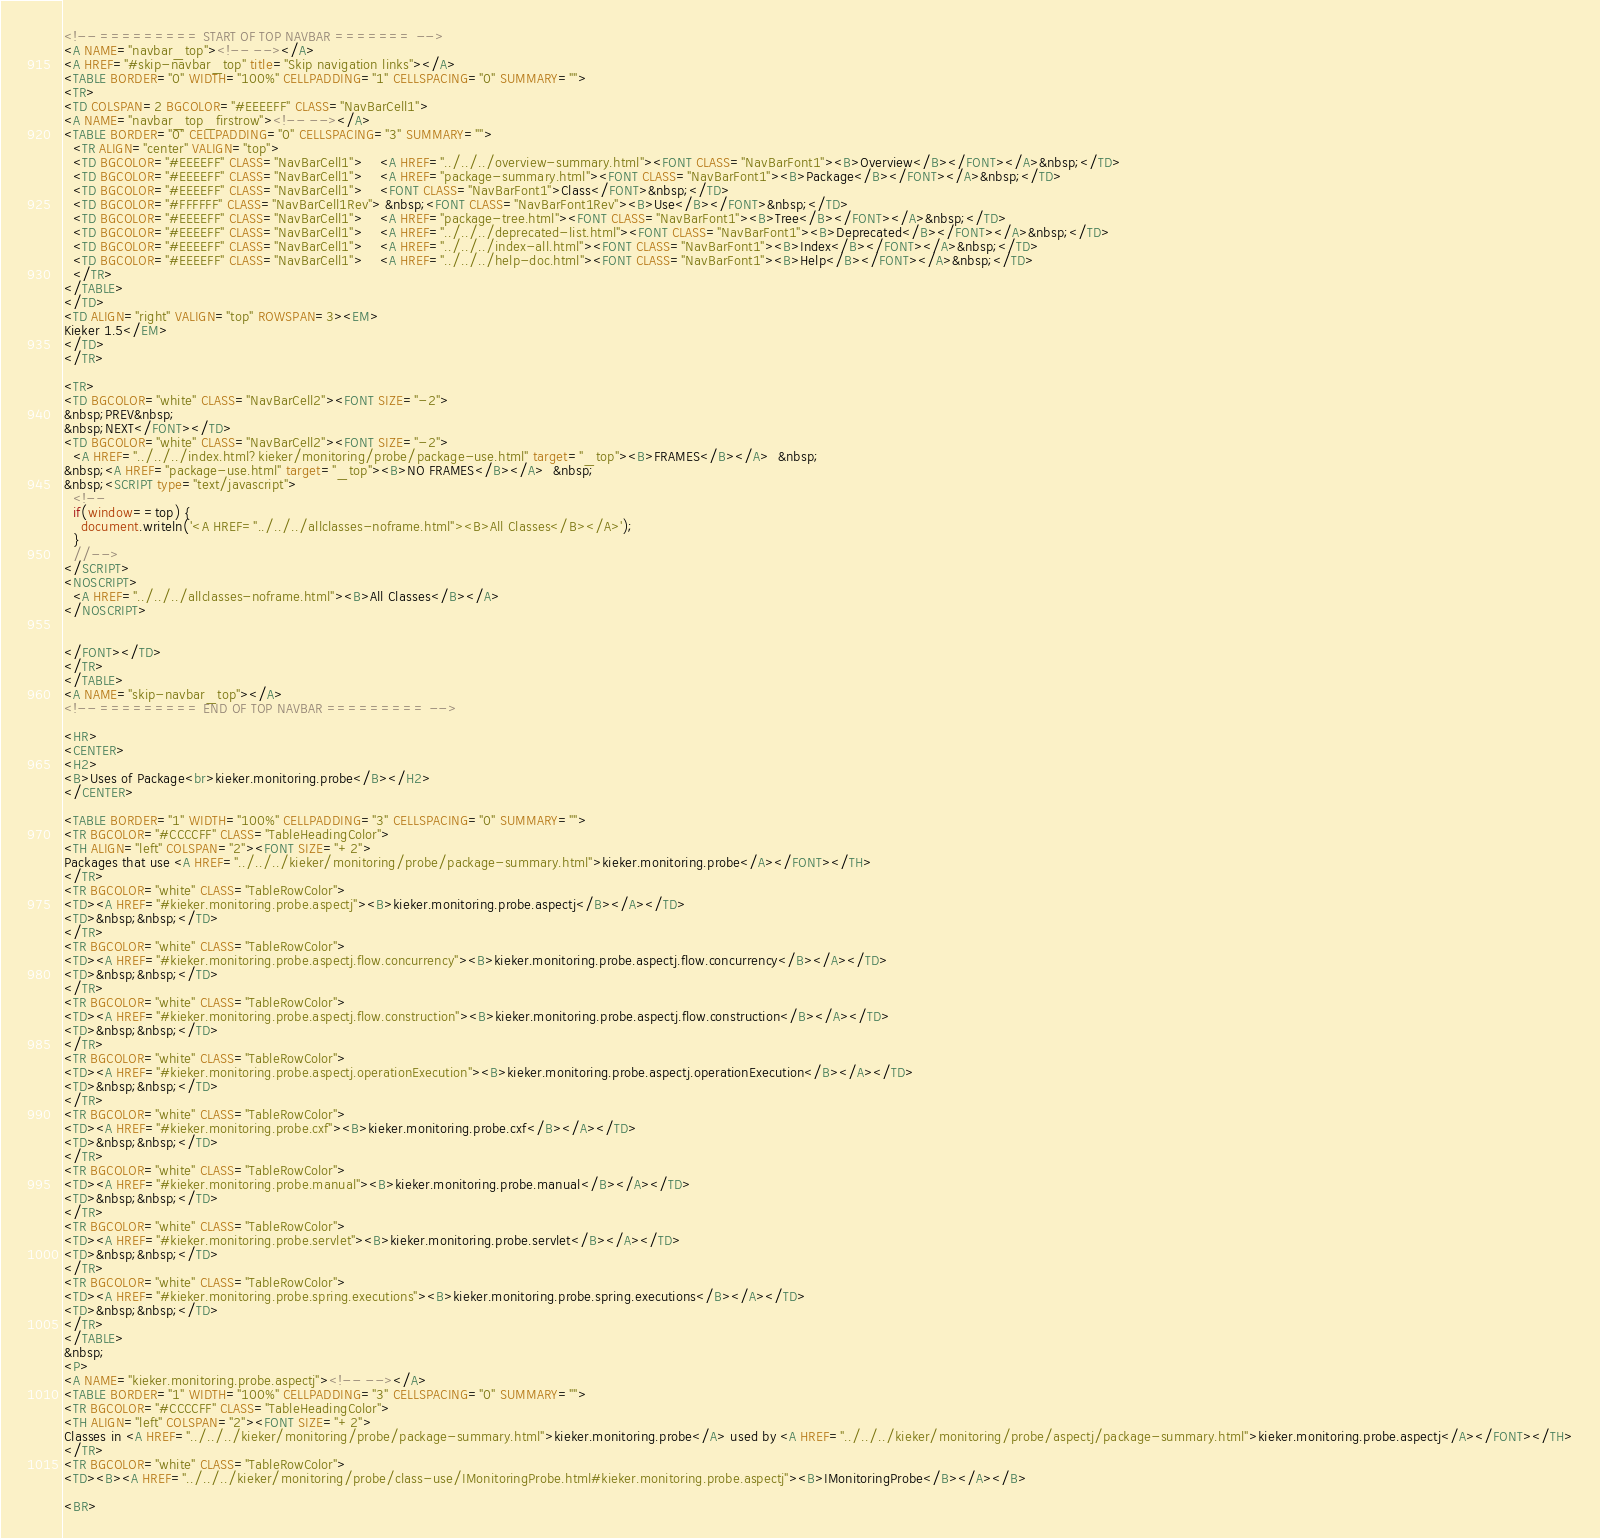Convert code to text. <code><loc_0><loc_0><loc_500><loc_500><_HTML_>
<!-- ========= START OF TOP NAVBAR ======= -->
<A NAME="navbar_top"><!-- --></A>
<A HREF="#skip-navbar_top" title="Skip navigation links"></A>
<TABLE BORDER="0" WIDTH="100%" CELLPADDING="1" CELLSPACING="0" SUMMARY="">
<TR>
<TD COLSPAN=2 BGCOLOR="#EEEEFF" CLASS="NavBarCell1">
<A NAME="navbar_top_firstrow"><!-- --></A>
<TABLE BORDER="0" CELLPADDING="0" CELLSPACING="3" SUMMARY="">
  <TR ALIGN="center" VALIGN="top">
  <TD BGCOLOR="#EEEEFF" CLASS="NavBarCell1">    <A HREF="../../../overview-summary.html"><FONT CLASS="NavBarFont1"><B>Overview</B></FONT></A>&nbsp;</TD>
  <TD BGCOLOR="#EEEEFF" CLASS="NavBarCell1">    <A HREF="package-summary.html"><FONT CLASS="NavBarFont1"><B>Package</B></FONT></A>&nbsp;</TD>
  <TD BGCOLOR="#EEEEFF" CLASS="NavBarCell1">    <FONT CLASS="NavBarFont1">Class</FONT>&nbsp;</TD>
  <TD BGCOLOR="#FFFFFF" CLASS="NavBarCell1Rev"> &nbsp;<FONT CLASS="NavBarFont1Rev"><B>Use</B></FONT>&nbsp;</TD>
  <TD BGCOLOR="#EEEEFF" CLASS="NavBarCell1">    <A HREF="package-tree.html"><FONT CLASS="NavBarFont1"><B>Tree</B></FONT></A>&nbsp;</TD>
  <TD BGCOLOR="#EEEEFF" CLASS="NavBarCell1">    <A HREF="../../../deprecated-list.html"><FONT CLASS="NavBarFont1"><B>Deprecated</B></FONT></A>&nbsp;</TD>
  <TD BGCOLOR="#EEEEFF" CLASS="NavBarCell1">    <A HREF="../../../index-all.html"><FONT CLASS="NavBarFont1"><B>Index</B></FONT></A>&nbsp;</TD>
  <TD BGCOLOR="#EEEEFF" CLASS="NavBarCell1">    <A HREF="../../../help-doc.html"><FONT CLASS="NavBarFont1"><B>Help</B></FONT></A>&nbsp;</TD>
  </TR>
</TABLE>
</TD>
<TD ALIGN="right" VALIGN="top" ROWSPAN=3><EM>
Kieker 1.5</EM>
</TD>
</TR>

<TR>
<TD BGCOLOR="white" CLASS="NavBarCell2"><FONT SIZE="-2">
&nbsp;PREV&nbsp;
&nbsp;NEXT</FONT></TD>
<TD BGCOLOR="white" CLASS="NavBarCell2"><FONT SIZE="-2">
  <A HREF="../../../index.html?kieker/monitoring/probe/package-use.html" target="_top"><B>FRAMES</B></A>  &nbsp;
&nbsp;<A HREF="package-use.html" target="_top"><B>NO FRAMES</B></A>  &nbsp;
&nbsp;<SCRIPT type="text/javascript">
  <!--
  if(window==top) {
    document.writeln('<A HREF="../../../allclasses-noframe.html"><B>All Classes</B></A>');
  }
  //-->
</SCRIPT>
<NOSCRIPT>
  <A HREF="../../../allclasses-noframe.html"><B>All Classes</B></A>
</NOSCRIPT>


</FONT></TD>
</TR>
</TABLE>
<A NAME="skip-navbar_top"></A>
<!-- ========= END OF TOP NAVBAR ========= -->

<HR>
<CENTER>
<H2>
<B>Uses of Package<br>kieker.monitoring.probe</B></H2>
</CENTER>

<TABLE BORDER="1" WIDTH="100%" CELLPADDING="3" CELLSPACING="0" SUMMARY="">
<TR BGCOLOR="#CCCCFF" CLASS="TableHeadingColor">
<TH ALIGN="left" COLSPAN="2"><FONT SIZE="+2">
Packages that use <A HREF="../../../kieker/monitoring/probe/package-summary.html">kieker.monitoring.probe</A></FONT></TH>
</TR>
<TR BGCOLOR="white" CLASS="TableRowColor">
<TD><A HREF="#kieker.monitoring.probe.aspectj"><B>kieker.monitoring.probe.aspectj</B></A></TD>
<TD>&nbsp;&nbsp;</TD>
</TR>
<TR BGCOLOR="white" CLASS="TableRowColor">
<TD><A HREF="#kieker.monitoring.probe.aspectj.flow.concurrency"><B>kieker.monitoring.probe.aspectj.flow.concurrency</B></A></TD>
<TD>&nbsp;&nbsp;</TD>
</TR>
<TR BGCOLOR="white" CLASS="TableRowColor">
<TD><A HREF="#kieker.monitoring.probe.aspectj.flow.construction"><B>kieker.monitoring.probe.aspectj.flow.construction</B></A></TD>
<TD>&nbsp;&nbsp;</TD>
</TR>
<TR BGCOLOR="white" CLASS="TableRowColor">
<TD><A HREF="#kieker.monitoring.probe.aspectj.operationExecution"><B>kieker.monitoring.probe.aspectj.operationExecution</B></A></TD>
<TD>&nbsp;&nbsp;</TD>
</TR>
<TR BGCOLOR="white" CLASS="TableRowColor">
<TD><A HREF="#kieker.monitoring.probe.cxf"><B>kieker.monitoring.probe.cxf</B></A></TD>
<TD>&nbsp;&nbsp;</TD>
</TR>
<TR BGCOLOR="white" CLASS="TableRowColor">
<TD><A HREF="#kieker.monitoring.probe.manual"><B>kieker.monitoring.probe.manual</B></A></TD>
<TD>&nbsp;&nbsp;</TD>
</TR>
<TR BGCOLOR="white" CLASS="TableRowColor">
<TD><A HREF="#kieker.monitoring.probe.servlet"><B>kieker.monitoring.probe.servlet</B></A></TD>
<TD>&nbsp;&nbsp;</TD>
</TR>
<TR BGCOLOR="white" CLASS="TableRowColor">
<TD><A HREF="#kieker.monitoring.probe.spring.executions"><B>kieker.monitoring.probe.spring.executions</B></A></TD>
<TD>&nbsp;&nbsp;</TD>
</TR>
</TABLE>
&nbsp;
<P>
<A NAME="kieker.monitoring.probe.aspectj"><!-- --></A>
<TABLE BORDER="1" WIDTH="100%" CELLPADDING="3" CELLSPACING="0" SUMMARY="">
<TR BGCOLOR="#CCCCFF" CLASS="TableHeadingColor">
<TH ALIGN="left" COLSPAN="2"><FONT SIZE="+2">
Classes in <A HREF="../../../kieker/monitoring/probe/package-summary.html">kieker.monitoring.probe</A> used by <A HREF="../../../kieker/monitoring/probe/aspectj/package-summary.html">kieker.monitoring.probe.aspectj</A></FONT></TH>
</TR>
<TR BGCOLOR="white" CLASS="TableRowColor">
<TD><B><A HREF="../../../kieker/monitoring/probe/class-use/IMonitoringProbe.html#kieker.monitoring.probe.aspectj"><B>IMonitoringProbe</B></A></B>

<BR></code> 